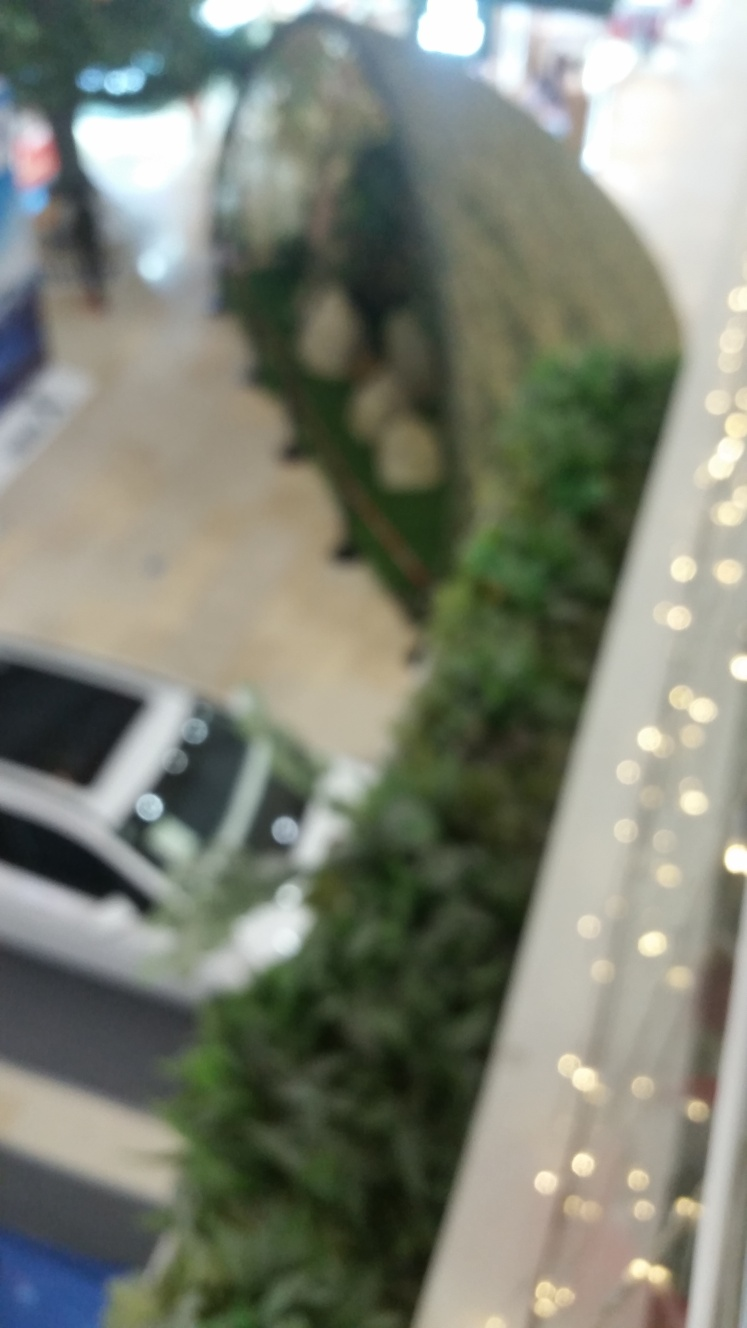Is the perspective overhead in the photo? Absolutely, the photo was taken from an overhead perspective, offering a bird's-eye view of the interior space. Although the image is blurred, it's evident that we are looking down onto a lower level from an upper floor, possibly within a shopping mall or similar venue. 